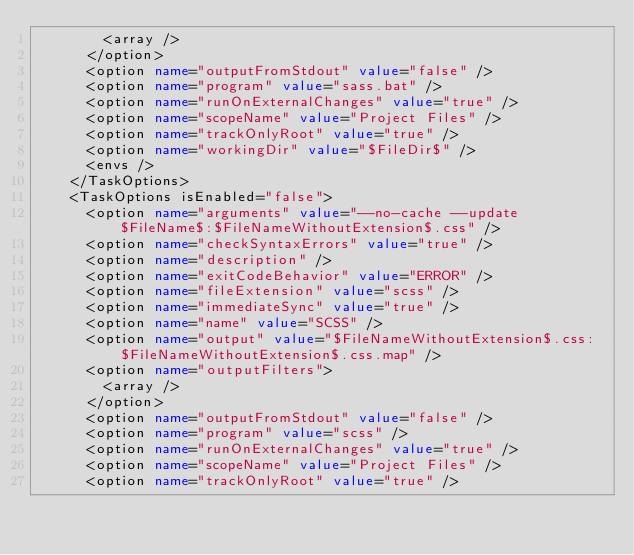<code> <loc_0><loc_0><loc_500><loc_500><_XML_>        <array />
      </option>
      <option name="outputFromStdout" value="false" />
      <option name="program" value="sass.bat" />
      <option name="runOnExternalChanges" value="true" />
      <option name="scopeName" value="Project Files" />
      <option name="trackOnlyRoot" value="true" />
      <option name="workingDir" value="$FileDir$" />
      <envs />
    </TaskOptions>
    <TaskOptions isEnabled="false">
      <option name="arguments" value="--no-cache --update $FileName$:$FileNameWithoutExtension$.css" />
      <option name="checkSyntaxErrors" value="true" />
      <option name="description" />
      <option name="exitCodeBehavior" value="ERROR" />
      <option name="fileExtension" value="scss" />
      <option name="immediateSync" value="true" />
      <option name="name" value="SCSS" />
      <option name="output" value="$FileNameWithoutExtension$.css:$FileNameWithoutExtension$.css.map" />
      <option name="outputFilters">
        <array />
      </option>
      <option name="outputFromStdout" value="false" />
      <option name="program" value="scss" />
      <option name="runOnExternalChanges" value="true" />
      <option name="scopeName" value="Project Files" />
      <option name="trackOnlyRoot" value="true" /></code> 